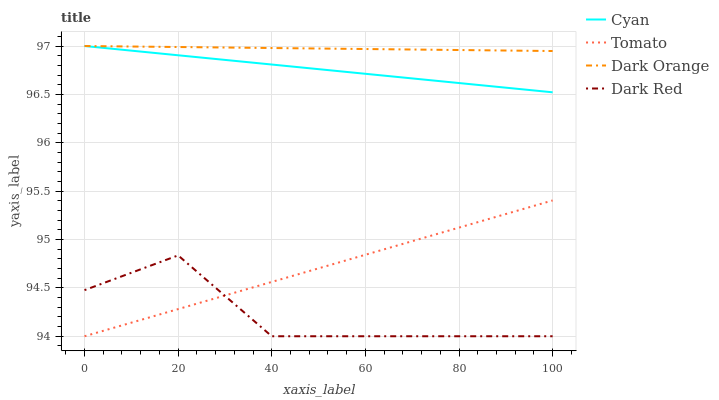Does Dark Red have the minimum area under the curve?
Answer yes or no. Yes. Does Dark Orange have the maximum area under the curve?
Answer yes or no. Yes. Does Cyan have the minimum area under the curve?
Answer yes or no. No. Does Cyan have the maximum area under the curve?
Answer yes or no. No. Is Tomato the smoothest?
Answer yes or no. Yes. Is Dark Red the roughest?
Answer yes or no. Yes. Is Cyan the smoothest?
Answer yes or no. No. Is Cyan the roughest?
Answer yes or no. No. Does Cyan have the lowest value?
Answer yes or no. No. Does Dark Orange have the highest value?
Answer yes or no. Yes. Does Dark Red have the highest value?
Answer yes or no. No. Is Dark Red less than Cyan?
Answer yes or no. Yes. Is Cyan greater than Dark Red?
Answer yes or no. Yes. Does Cyan intersect Dark Orange?
Answer yes or no. Yes. Is Cyan less than Dark Orange?
Answer yes or no. No. Is Cyan greater than Dark Orange?
Answer yes or no. No. Does Dark Red intersect Cyan?
Answer yes or no. No. 